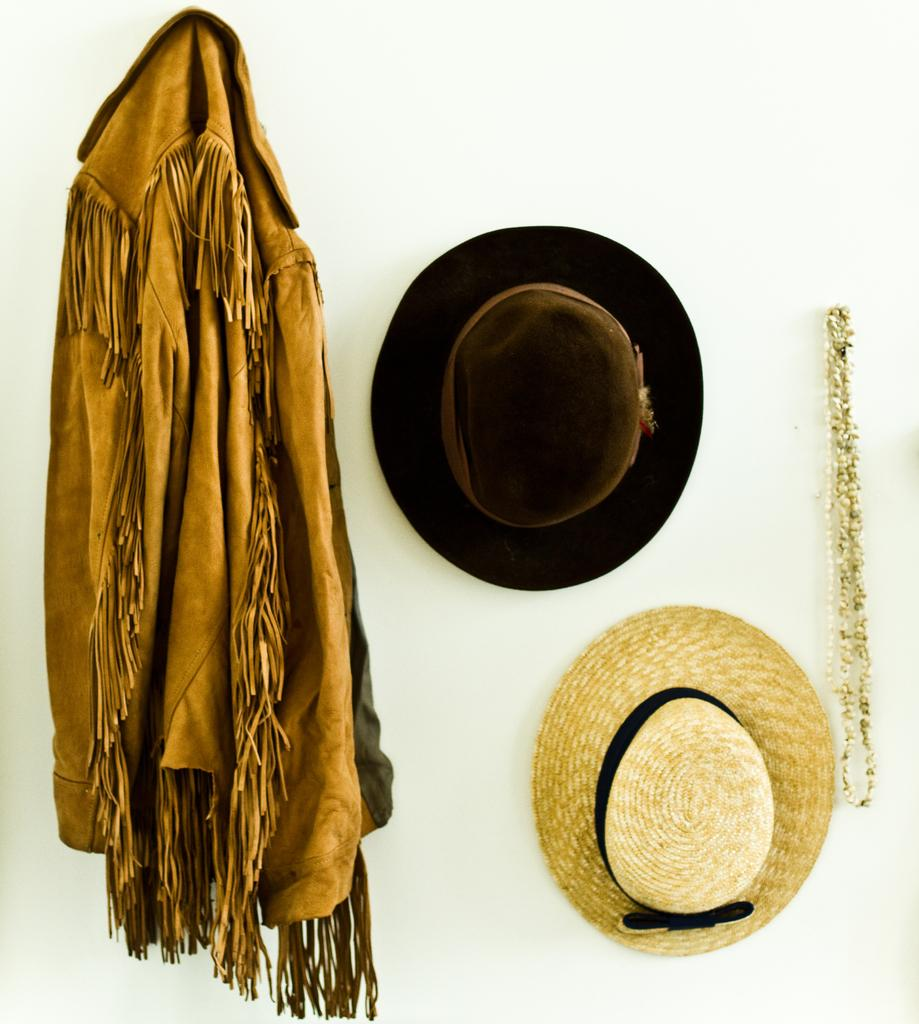What is located on the left side of the image? There is a coat on the left side of the image. What other items are near the coat? There are two hats beside the coat. What is the chain beside the hats used for? The chain beside the hats is used to attach the items to the wall. How are the coat, hats, and chain connected to the wall? All the items (coat, hats, and chain) are attached to the wall. What is the weight of the island in the image? There is no island present in the image, so it is not possible to determine its weight. 